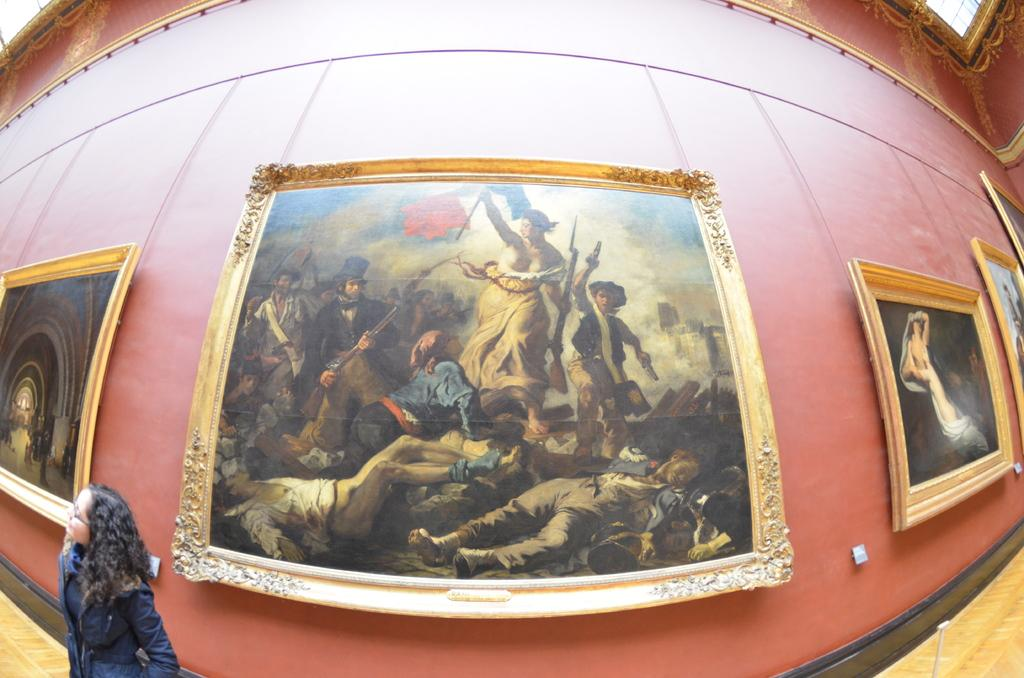What is attached to the wall in the image? There are frames attached to the wall in the image. What part of a building can be seen in the image? The inner part of a building is visible in the image. Can you describe the presence of a person in the image? Yes, there is a person in the image. What is the name of the toy that the person is holding in the image? There are no toys present in the image, and therefore no such activity can be observed. What type of flooring is visible in the image? The provided facts do not mention the flooring, so it cannot be determined from the image. 